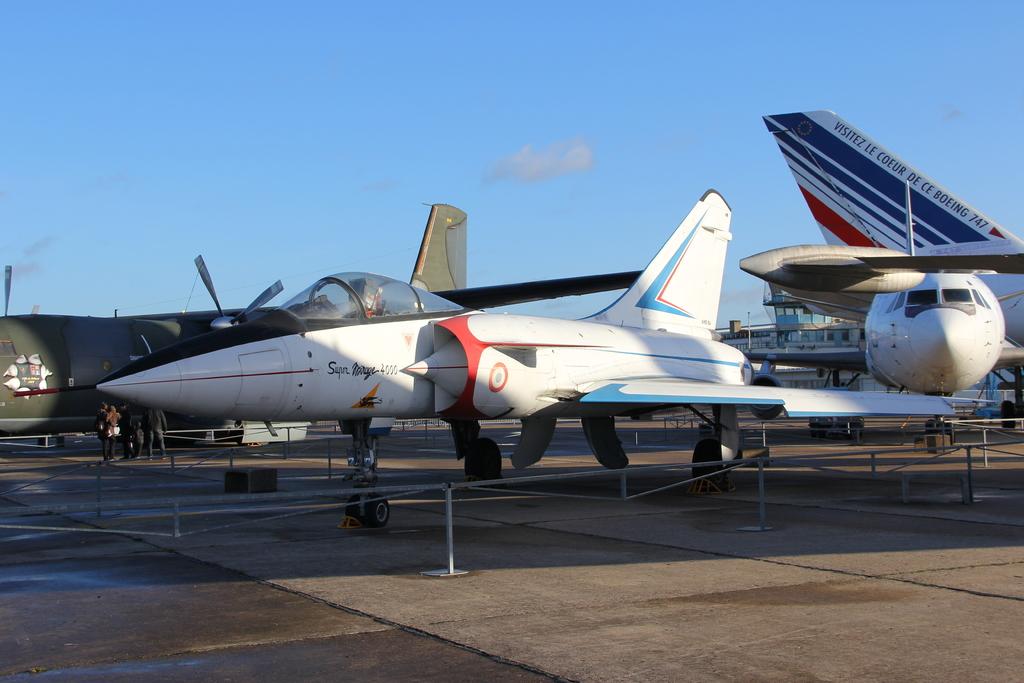What is written on the boeing 747 in the back?
Give a very brief answer. Visitez le coeur de ce boeing 747. 